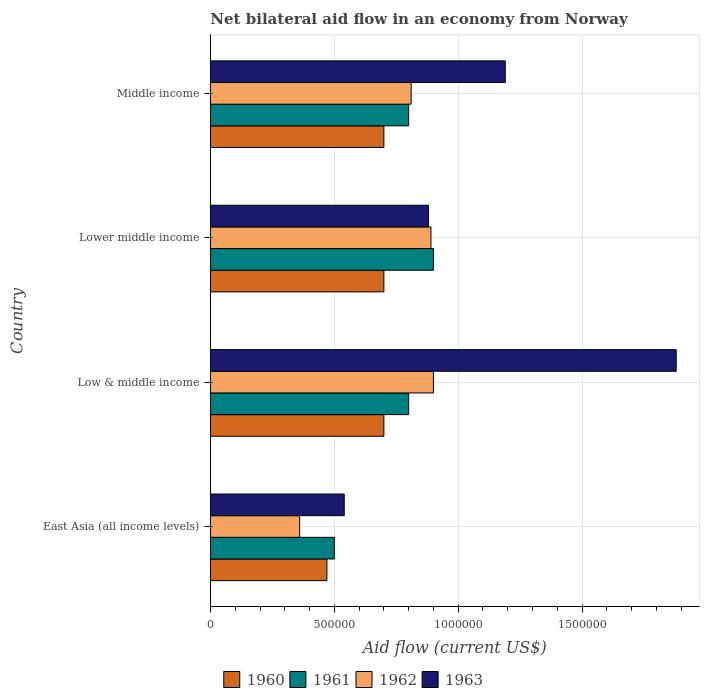How many different coloured bars are there?
Provide a succinct answer. 4. How many groups of bars are there?
Ensure brevity in your answer.  4. What is the label of the 1st group of bars from the top?
Your answer should be very brief. Middle income. Across all countries, what is the maximum net bilateral aid flow in 1962?
Your answer should be compact. 9.00e+05. Across all countries, what is the minimum net bilateral aid flow in 1961?
Your response must be concise. 5.00e+05. In which country was the net bilateral aid flow in 1961 maximum?
Your answer should be compact. Lower middle income. In which country was the net bilateral aid flow in 1962 minimum?
Provide a short and direct response. East Asia (all income levels). What is the total net bilateral aid flow in 1960 in the graph?
Ensure brevity in your answer.  2.57e+06. What is the difference between the net bilateral aid flow in 1962 in East Asia (all income levels) and that in Middle income?
Ensure brevity in your answer.  -4.50e+05. What is the difference between the net bilateral aid flow in 1961 in Lower middle income and the net bilateral aid flow in 1962 in Middle income?
Your answer should be compact. 9.00e+04. What is the average net bilateral aid flow in 1962 per country?
Give a very brief answer. 7.40e+05. What is the difference between the net bilateral aid flow in 1961 and net bilateral aid flow in 1962 in East Asia (all income levels)?
Your answer should be very brief. 1.40e+05. What is the ratio of the net bilateral aid flow in 1961 in Lower middle income to that in Middle income?
Offer a very short reply. 1.12. Is the net bilateral aid flow in 1962 in Low & middle income less than that in Middle income?
Give a very brief answer. No. What is the difference between the highest and the second highest net bilateral aid flow in 1963?
Your answer should be very brief. 6.90e+05. Is the sum of the net bilateral aid flow in 1962 in East Asia (all income levels) and Middle income greater than the maximum net bilateral aid flow in 1960 across all countries?
Make the answer very short. Yes. What does the 4th bar from the top in Low & middle income represents?
Your answer should be compact. 1960. What does the 4th bar from the bottom in Low & middle income represents?
Give a very brief answer. 1963. Are all the bars in the graph horizontal?
Provide a short and direct response. Yes. How many countries are there in the graph?
Your answer should be very brief. 4. Where does the legend appear in the graph?
Offer a very short reply. Bottom center. How many legend labels are there?
Your answer should be very brief. 4. What is the title of the graph?
Provide a succinct answer. Net bilateral aid flow in an economy from Norway. Does "2010" appear as one of the legend labels in the graph?
Offer a very short reply. No. What is the label or title of the X-axis?
Offer a very short reply. Aid flow (current US$). What is the label or title of the Y-axis?
Provide a succinct answer. Country. What is the Aid flow (current US$) in 1960 in East Asia (all income levels)?
Make the answer very short. 4.70e+05. What is the Aid flow (current US$) in 1961 in East Asia (all income levels)?
Give a very brief answer. 5.00e+05. What is the Aid flow (current US$) of 1963 in East Asia (all income levels)?
Provide a succinct answer. 5.40e+05. What is the Aid flow (current US$) of 1960 in Low & middle income?
Make the answer very short. 7.00e+05. What is the Aid flow (current US$) in 1963 in Low & middle income?
Offer a very short reply. 1.88e+06. What is the Aid flow (current US$) in 1961 in Lower middle income?
Provide a short and direct response. 9.00e+05. What is the Aid flow (current US$) in 1962 in Lower middle income?
Offer a terse response. 8.90e+05. What is the Aid flow (current US$) in 1963 in Lower middle income?
Offer a terse response. 8.80e+05. What is the Aid flow (current US$) in 1962 in Middle income?
Make the answer very short. 8.10e+05. What is the Aid flow (current US$) of 1963 in Middle income?
Provide a short and direct response. 1.19e+06. Across all countries, what is the maximum Aid flow (current US$) in 1962?
Your answer should be compact. 9.00e+05. Across all countries, what is the maximum Aid flow (current US$) in 1963?
Your answer should be compact. 1.88e+06. Across all countries, what is the minimum Aid flow (current US$) of 1960?
Your answer should be very brief. 4.70e+05. Across all countries, what is the minimum Aid flow (current US$) in 1961?
Keep it short and to the point. 5.00e+05. Across all countries, what is the minimum Aid flow (current US$) of 1962?
Your answer should be very brief. 3.60e+05. Across all countries, what is the minimum Aid flow (current US$) of 1963?
Make the answer very short. 5.40e+05. What is the total Aid flow (current US$) of 1960 in the graph?
Your response must be concise. 2.57e+06. What is the total Aid flow (current US$) of 1962 in the graph?
Offer a terse response. 2.96e+06. What is the total Aid flow (current US$) of 1963 in the graph?
Make the answer very short. 4.49e+06. What is the difference between the Aid flow (current US$) of 1961 in East Asia (all income levels) and that in Low & middle income?
Keep it short and to the point. -3.00e+05. What is the difference between the Aid flow (current US$) in 1962 in East Asia (all income levels) and that in Low & middle income?
Offer a very short reply. -5.40e+05. What is the difference between the Aid flow (current US$) in 1963 in East Asia (all income levels) and that in Low & middle income?
Provide a short and direct response. -1.34e+06. What is the difference between the Aid flow (current US$) of 1960 in East Asia (all income levels) and that in Lower middle income?
Give a very brief answer. -2.30e+05. What is the difference between the Aid flow (current US$) in 1961 in East Asia (all income levels) and that in Lower middle income?
Make the answer very short. -4.00e+05. What is the difference between the Aid flow (current US$) in 1962 in East Asia (all income levels) and that in Lower middle income?
Ensure brevity in your answer.  -5.30e+05. What is the difference between the Aid flow (current US$) in 1960 in East Asia (all income levels) and that in Middle income?
Provide a succinct answer. -2.30e+05. What is the difference between the Aid flow (current US$) of 1961 in East Asia (all income levels) and that in Middle income?
Give a very brief answer. -3.00e+05. What is the difference between the Aid flow (current US$) of 1962 in East Asia (all income levels) and that in Middle income?
Offer a very short reply. -4.50e+05. What is the difference between the Aid flow (current US$) of 1963 in East Asia (all income levels) and that in Middle income?
Provide a short and direct response. -6.50e+05. What is the difference between the Aid flow (current US$) of 1960 in Low & middle income and that in Lower middle income?
Your answer should be very brief. 0. What is the difference between the Aid flow (current US$) in 1961 in Low & middle income and that in Lower middle income?
Offer a very short reply. -1.00e+05. What is the difference between the Aid flow (current US$) in 1962 in Low & middle income and that in Lower middle income?
Your response must be concise. 10000. What is the difference between the Aid flow (current US$) in 1963 in Low & middle income and that in Lower middle income?
Offer a very short reply. 1.00e+06. What is the difference between the Aid flow (current US$) of 1960 in Low & middle income and that in Middle income?
Make the answer very short. 0. What is the difference between the Aid flow (current US$) of 1963 in Low & middle income and that in Middle income?
Offer a terse response. 6.90e+05. What is the difference between the Aid flow (current US$) in 1963 in Lower middle income and that in Middle income?
Your answer should be very brief. -3.10e+05. What is the difference between the Aid flow (current US$) in 1960 in East Asia (all income levels) and the Aid flow (current US$) in 1961 in Low & middle income?
Provide a succinct answer. -3.30e+05. What is the difference between the Aid flow (current US$) in 1960 in East Asia (all income levels) and the Aid flow (current US$) in 1962 in Low & middle income?
Keep it short and to the point. -4.30e+05. What is the difference between the Aid flow (current US$) in 1960 in East Asia (all income levels) and the Aid flow (current US$) in 1963 in Low & middle income?
Make the answer very short. -1.41e+06. What is the difference between the Aid flow (current US$) in 1961 in East Asia (all income levels) and the Aid flow (current US$) in 1962 in Low & middle income?
Your answer should be compact. -4.00e+05. What is the difference between the Aid flow (current US$) of 1961 in East Asia (all income levels) and the Aid flow (current US$) of 1963 in Low & middle income?
Make the answer very short. -1.38e+06. What is the difference between the Aid flow (current US$) in 1962 in East Asia (all income levels) and the Aid flow (current US$) in 1963 in Low & middle income?
Your answer should be compact. -1.52e+06. What is the difference between the Aid flow (current US$) in 1960 in East Asia (all income levels) and the Aid flow (current US$) in 1961 in Lower middle income?
Offer a very short reply. -4.30e+05. What is the difference between the Aid flow (current US$) in 1960 in East Asia (all income levels) and the Aid flow (current US$) in 1962 in Lower middle income?
Your answer should be compact. -4.20e+05. What is the difference between the Aid flow (current US$) in 1960 in East Asia (all income levels) and the Aid flow (current US$) in 1963 in Lower middle income?
Offer a very short reply. -4.10e+05. What is the difference between the Aid flow (current US$) of 1961 in East Asia (all income levels) and the Aid flow (current US$) of 1962 in Lower middle income?
Your answer should be compact. -3.90e+05. What is the difference between the Aid flow (current US$) in 1961 in East Asia (all income levels) and the Aid flow (current US$) in 1963 in Lower middle income?
Make the answer very short. -3.80e+05. What is the difference between the Aid flow (current US$) in 1962 in East Asia (all income levels) and the Aid flow (current US$) in 1963 in Lower middle income?
Offer a very short reply. -5.20e+05. What is the difference between the Aid flow (current US$) in 1960 in East Asia (all income levels) and the Aid flow (current US$) in 1961 in Middle income?
Your answer should be compact. -3.30e+05. What is the difference between the Aid flow (current US$) of 1960 in East Asia (all income levels) and the Aid flow (current US$) of 1962 in Middle income?
Keep it short and to the point. -3.40e+05. What is the difference between the Aid flow (current US$) of 1960 in East Asia (all income levels) and the Aid flow (current US$) of 1963 in Middle income?
Your response must be concise. -7.20e+05. What is the difference between the Aid flow (current US$) of 1961 in East Asia (all income levels) and the Aid flow (current US$) of 1962 in Middle income?
Give a very brief answer. -3.10e+05. What is the difference between the Aid flow (current US$) in 1961 in East Asia (all income levels) and the Aid flow (current US$) in 1963 in Middle income?
Your response must be concise. -6.90e+05. What is the difference between the Aid flow (current US$) of 1962 in East Asia (all income levels) and the Aid flow (current US$) of 1963 in Middle income?
Provide a succinct answer. -8.30e+05. What is the difference between the Aid flow (current US$) in 1960 in Low & middle income and the Aid flow (current US$) in 1961 in Lower middle income?
Provide a short and direct response. -2.00e+05. What is the difference between the Aid flow (current US$) of 1960 in Low & middle income and the Aid flow (current US$) of 1962 in Lower middle income?
Provide a short and direct response. -1.90e+05. What is the difference between the Aid flow (current US$) of 1961 in Low & middle income and the Aid flow (current US$) of 1962 in Lower middle income?
Your answer should be compact. -9.00e+04. What is the difference between the Aid flow (current US$) in 1960 in Low & middle income and the Aid flow (current US$) in 1962 in Middle income?
Make the answer very short. -1.10e+05. What is the difference between the Aid flow (current US$) in 1960 in Low & middle income and the Aid flow (current US$) in 1963 in Middle income?
Offer a terse response. -4.90e+05. What is the difference between the Aid flow (current US$) in 1961 in Low & middle income and the Aid flow (current US$) in 1963 in Middle income?
Offer a very short reply. -3.90e+05. What is the difference between the Aid flow (current US$) of 1960 in Lower middle income and the Aid flow (current US$) of 1962 in Middle income?
Ensure brevity in your answer.  -1.10e+05. What is the difference between the Aid flow (current US$) of 1960 in Lower middle income and the Aid flow (current US$) of 1963 in Middle income?
Your answer should be very brief. -4.90e+05. What is the difference between the Aid flow (current US$) of 1961 in Lower middle income and the Aid flow (current US$) of 1962 in Middle income?
Your answer should be very brief. 9.00e+04. What is the average Aid flow (current US$) in 1960 per country?
Provide a short and direct response. 6.42e+05. What is the average Aid flow (current US$) of 1961 per country?
Offer a very short reply. 7.50e+05. What is the average Aid flow (current US$) in 1962 per country?
Your response must be concise. 7.40e+05. What is the average Aid flow (current US$) in 1963 per country?
Your response must be concise. 1.12e+06. What is the difference between the Aid flow (current US$) in 1960 and Aid flow (current US$) in 1963 in East Asia (all income levels)?
Ensure brevity in your answer.  -7.00e+04. What is the difference between the Aid flow (current US$) of 1961 and Aid flow (current US$) of 1962 in East Asia (all income levels)?
Your answer should be very brief. 1.40e+05. What is the difference between the Aid flow (current US$) in 1961 and Aid flow (current US$) in 1963 in East Asia (all income levels)?
Offer a terse response. -4.00e+04. What is the difference between the Aid flow (current US$) of 1960 and Aid flow (current US$) of 1961 in Low & middle income?
Provide a short and direct response. -1.00e+05. What is the difference between the Aid flow (current US$) in 1960 and Aid flow (current US$) in 1962 in Low & middle income?
Give a very brief answer. -2.00e+05. What is the difference between the Aid flow (current US$) in 1960 and Aid flow (current US$) in 1963 in Low & middle income?
Provide a short and direct response. -1.18e+06. What is the difference between the Aid flow (current US$) of 1961 and Aid flow (current US$) of 1962 in Low & middle income?
Give a very brief answer. -1.00e+05. What is the difference between the Aid flow (current US$) of 1961 and Aid flow (current US$) of 1963 in Low & middle income?
Keep it short and to the point. -1.08e+06. What is the difference between the Aid flow (current US$) of 1962 and Aid flow (current US$) of 1963 in Low & middle income?
Offer a very short reply. -9.80e+05. What is the difference between the Aid flow (current US$) in 1960 and Aid flow (current US$) in 1962 in Lower middle income?
Give a very brief answer. -1.90e+05. What is the difference between the Aid flow (current US$) of 1961 and Aid flow (current US$) of 1963 in Lower middle income?
Give a very brief answer. 2.00e+04. What is the difference between the Aid flow (current US$) in 1962 and Aid flow (current US$) in 1963 in Lower middle income?
Your answer should be very brief. 10000. What is the difference between the Aid flow (current US$) of 1960 and Aid flow (current US$) of 1961 in Middle income?
Your response must be concise. -1.00e+05. What is the difference between the Aid flow (current US$) of 1960 and Aid flow (current US$) of 1963 in Middle income?
Provide a short and direct response. -4.90e+05. What is the difference between the Aid flow (current US$) in 1961 and Aid flow (current US$) in 1962 in Middle income?
Your response must be concise. -10000. What is the difference between the Aid flow (current US$) in 1961 and Aid flow (current US$) in 1963 in Middle income?
Ensure brevity in your answer.  -3.90e+05. What is the difference between the Aid flow (current US$) in 1962 and Aid flow (current US$) in 1963 in Middle income?
Your response must be concise. -3.80e+05. What is the ratio of the Aid flow (current US$) of 1960 in East Asia (all income levels) to that in Low & middle income?
Your response must be concise. 0.67. What is the ratio of the Aid flow (current US$) in 1961 in East Asia (all income levels) to that in Low & middle income?
Provide a short and direct response. 0.62. What is the ratio of the Aid flow (current US$) of 1963 in East Asia (all income levels) to that in Low & middle income?
Keep it short and to the point. 0.29. What is the ratio of the Aid flow (current US$) in 1960 in East Asia (all income levels) to that in Lower middle income?
Make the answer very short. 0.67. What is the ratio of the Aid flow (current US$) of 1961 in East Asia (all income levels) to that in Lower middle income?
Your answer should be compact. 0.56. What is the ratio of the Aid flow (current US$) in 1962 in East Asia (all income levels) to that in Lower middle income?
Give a very brief answer. 0.4. What is the ratio of the Aid flow (current US$) of 1963 in East Asia (all income levels) to that in Lower middle income?
Make the answer very short. 0.61. What is the ratio of the Aid flow (current US$) of 1960 in East Asia (all income levels) to that in Middle income?
Make the answer very short. 0.67. What is the ratio of the Aid flow (current US$) in 1961 in East Asia (all income levels) to that in Middle income?
Provide a short and direct response. 0.62. What is the ratio of the Aid flow (current US$) of 1962 in East Asia (all income levels) to that in Middle income?
Provide a short and direct response. 0.44. What is the ratio of the Aid flow (current US$) in 1963 in East Asia (all income levels) to that in Middle income?
Your response must be concise. 0.45. What is the ratio of the Aid flow (current US$) in 1960 in Low & middle income to that in Lower middle income?
Your answer should be very brief. 1. What is the ratio of the Aid flow (current US$) in 1962 in Low & middle income to that in Lower middle income?
Ensure brevity in your answer.  1.01. What is the ratio of the Aid flow (current US$) in 1963 in Low & middle income to that in Lower middle income?
Your answer should be compact. 2.14. What is the ratio of the Aid flow (current US$) of 1960 in Low & middle income to that in Middle income?
Provide a short and direct response. 1. What is the ratio of the Aid flow (current US$) of 1961 in Low & middle income to that in Middle income?
Keep it short and to the point. 1. What is the ratio of the Aid flow (current US$) in 1963 in Low & middle income to that in Middle income?
Your answer should be very brief. 1.58. What is the ratio of the Aid flow (current US$) of 1962 in Lower middle income to that in Middle income?
Provide a succinct answer. 1.1. What is the ratio of the Aid flow (current US$) in 1963 in Lower middle income to that in Middle income?
Ensure brevity in your answer.  0.74. What is the difference between the highest and the second highest Aid flow (current US$) of 1960?
Your answer should be very brief. 0. What is the difference between the highest and the second highest Aid flow (current US$) in 1961?
Ensure brevity in your answer.  1.00e+05. What is the difference between the highest and the second highest Aid flow (current US$) of 1962?
Your answer should be compact. 10000. What is the difference between the highest and the second highest Aid flow (current US$) of 1963?
Your answer should be compact. 6.90e+05. What is the difference between the highest and the lowest Aid flow (current US$) in 1962?
Your answer should be very brief. 5.40e+05. What is the difference between the highest and the lowest Aid flow (current US$) in 1963?
Your answer should be compact. 1.34e+06. 